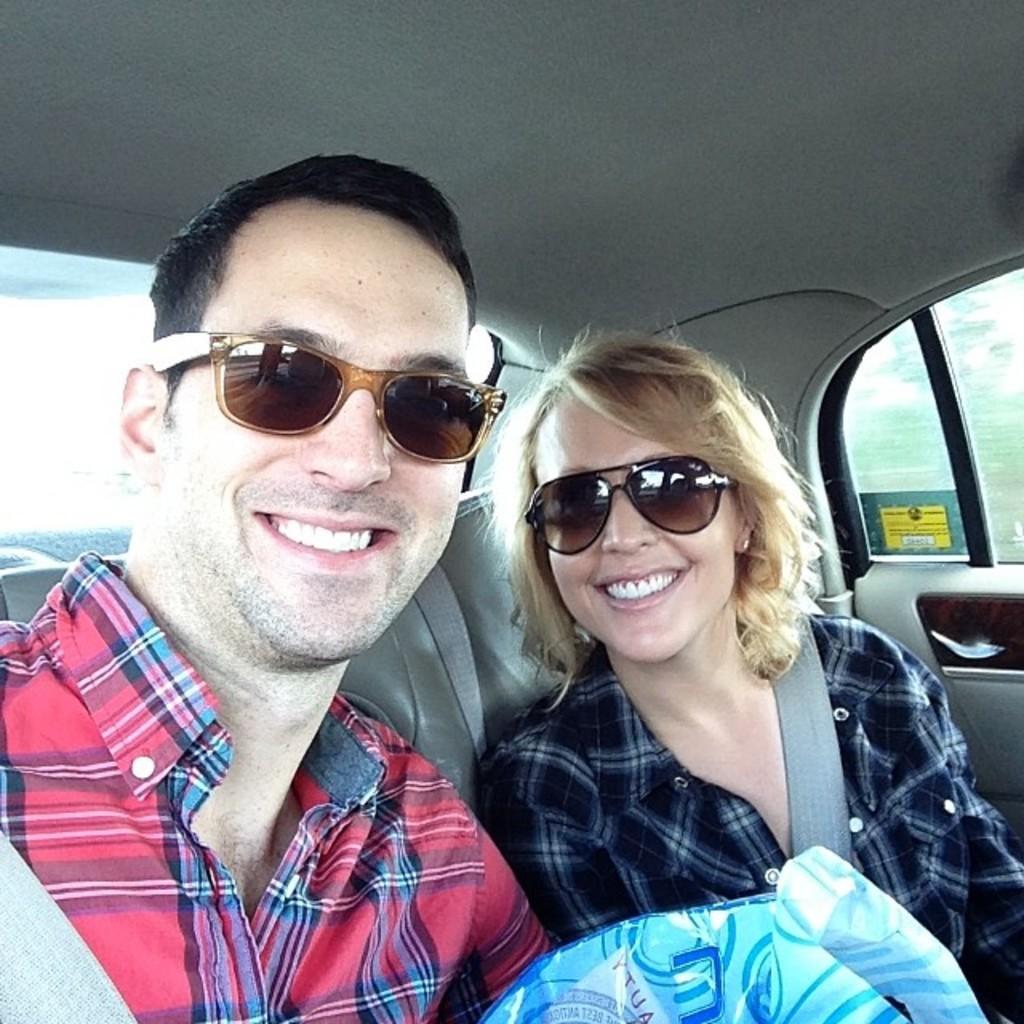Please provide a concise description of this image. There are two people man and woman sitting in a car and smiling. 